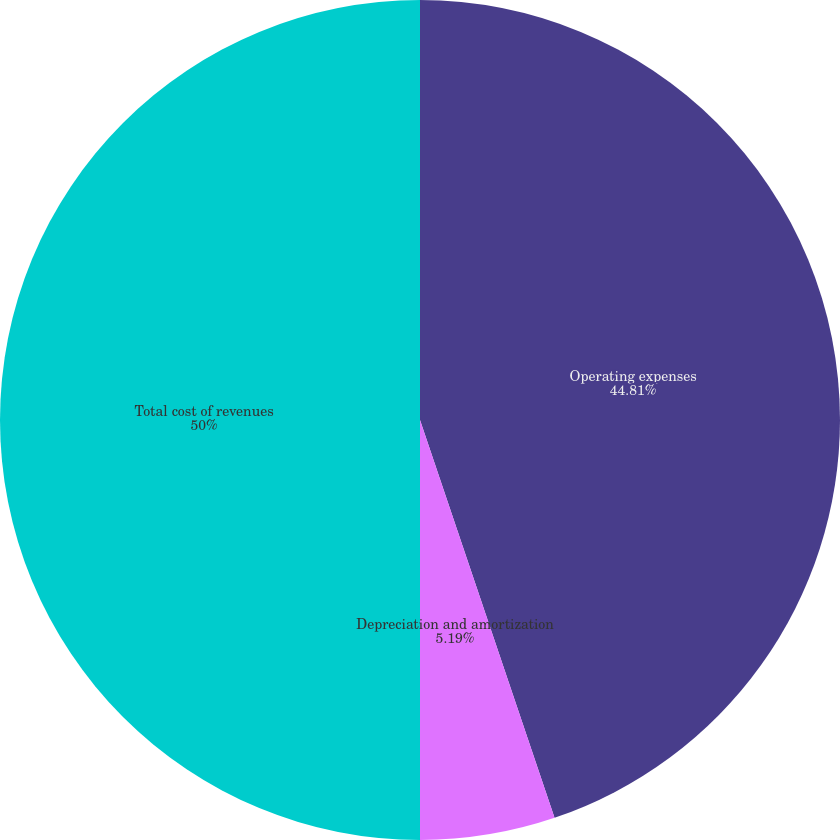<chart> <loc_0><loc_0><loc_500><loc_500><pie_chart><fcel>Operating expenses<fcel>Depreciation and amortization<fcel>Total cost of revenues<nl><fcel>44.81%<fcel>5.19%<fcel>50.0%<nl></chart> 